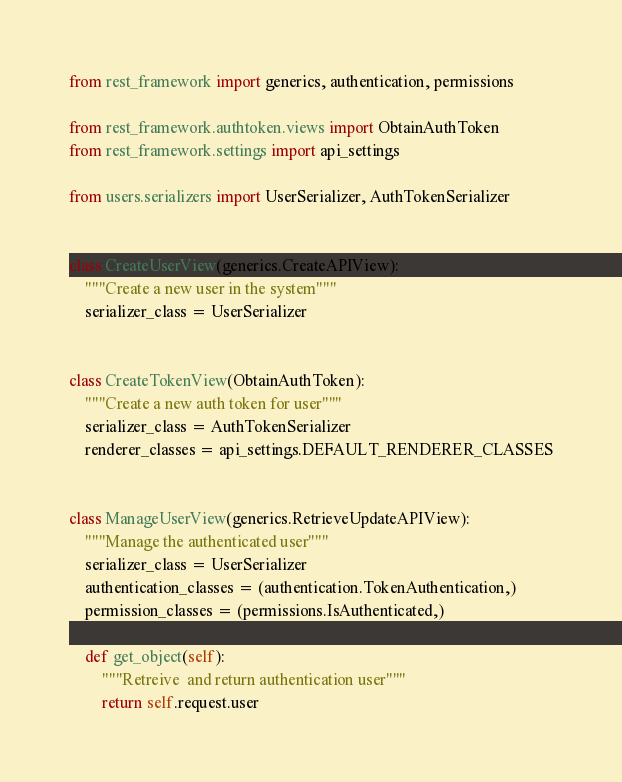<code> <loc_0><loc_0><loc_500><loc_500><_Python_>from rest_framework import generics, authentication, permissions

from rest_framework.authtoken.views import ObtainAuthToken
from rest_framework.settings import api_settings

from users.serializers import UserSerializer, AuthTokenSerializer


class CreateUserView(generics.CreateAPIView):
    """Create a new user in the system"""
    serializer_class = UserSerializer


class CreateTokenView(ObtainAuthToken):
    """Create a new auth token for user"""
    serializer_class = AuthTokenSerializer
    renderer_classes = api_settings.DEFAULT_RENDERER_CLASSES


class ManageUserView(generics.RetrieveUpdateAPIView):
    """Manage the authenticated user"""
    serializer_class = UserSerializer
    authentication_classes = (authentication.TokenAuthentication,)
    permission_classes = (permissions.IsAuthenticated,)

    def get_object(self):
        """Retreive  and return authentication user"""
        return self.request.user</code> 